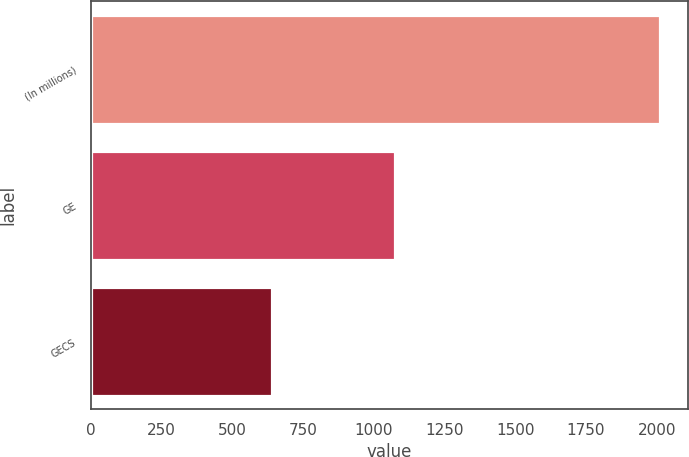<chart> <loc_0><loc_0><loc_500><loc_500><bar_chart><fcel>(In millions)<fcel>GE<fcel>GECS<nl><fcel>2010<fcel>1073<fcel>640<nl></chart> 